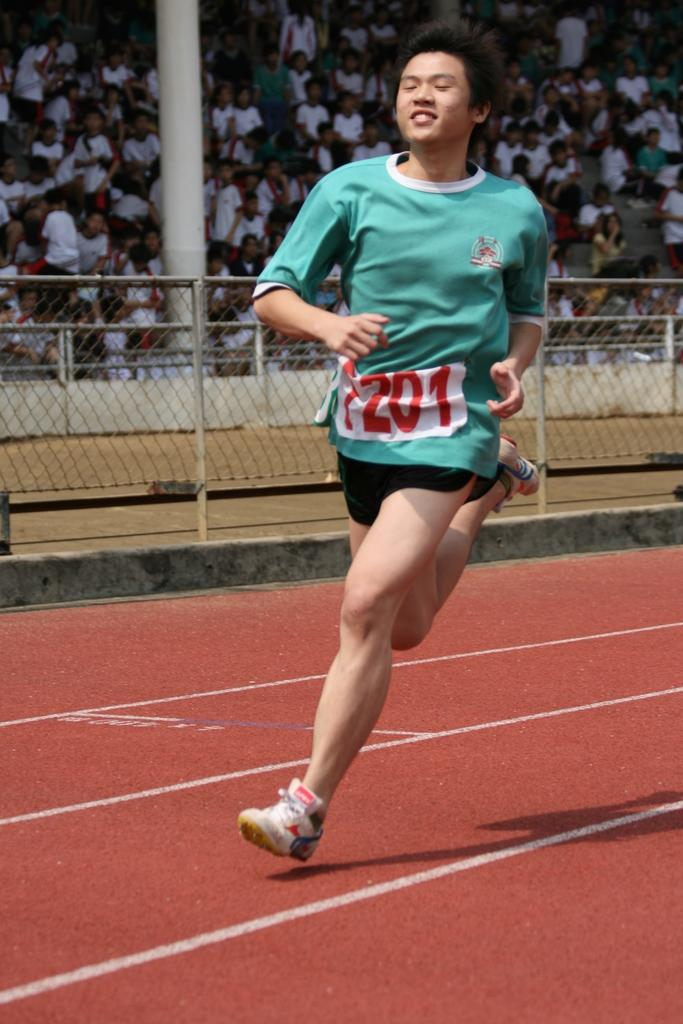What is the person in the image wearing? The person is wearing a green T-shirt. What is the person in the image doing? The person is running. What can be seen in the background of the image? There is fencing and some persons standing and sitting in the background of the image. How much snow can be seen on the ground in the image? There is no snow visible in the image. What type of spot is present on the person's green T-shirt in the image? There is no mention of a spot on the person's green T-shirt in the provided facts. 